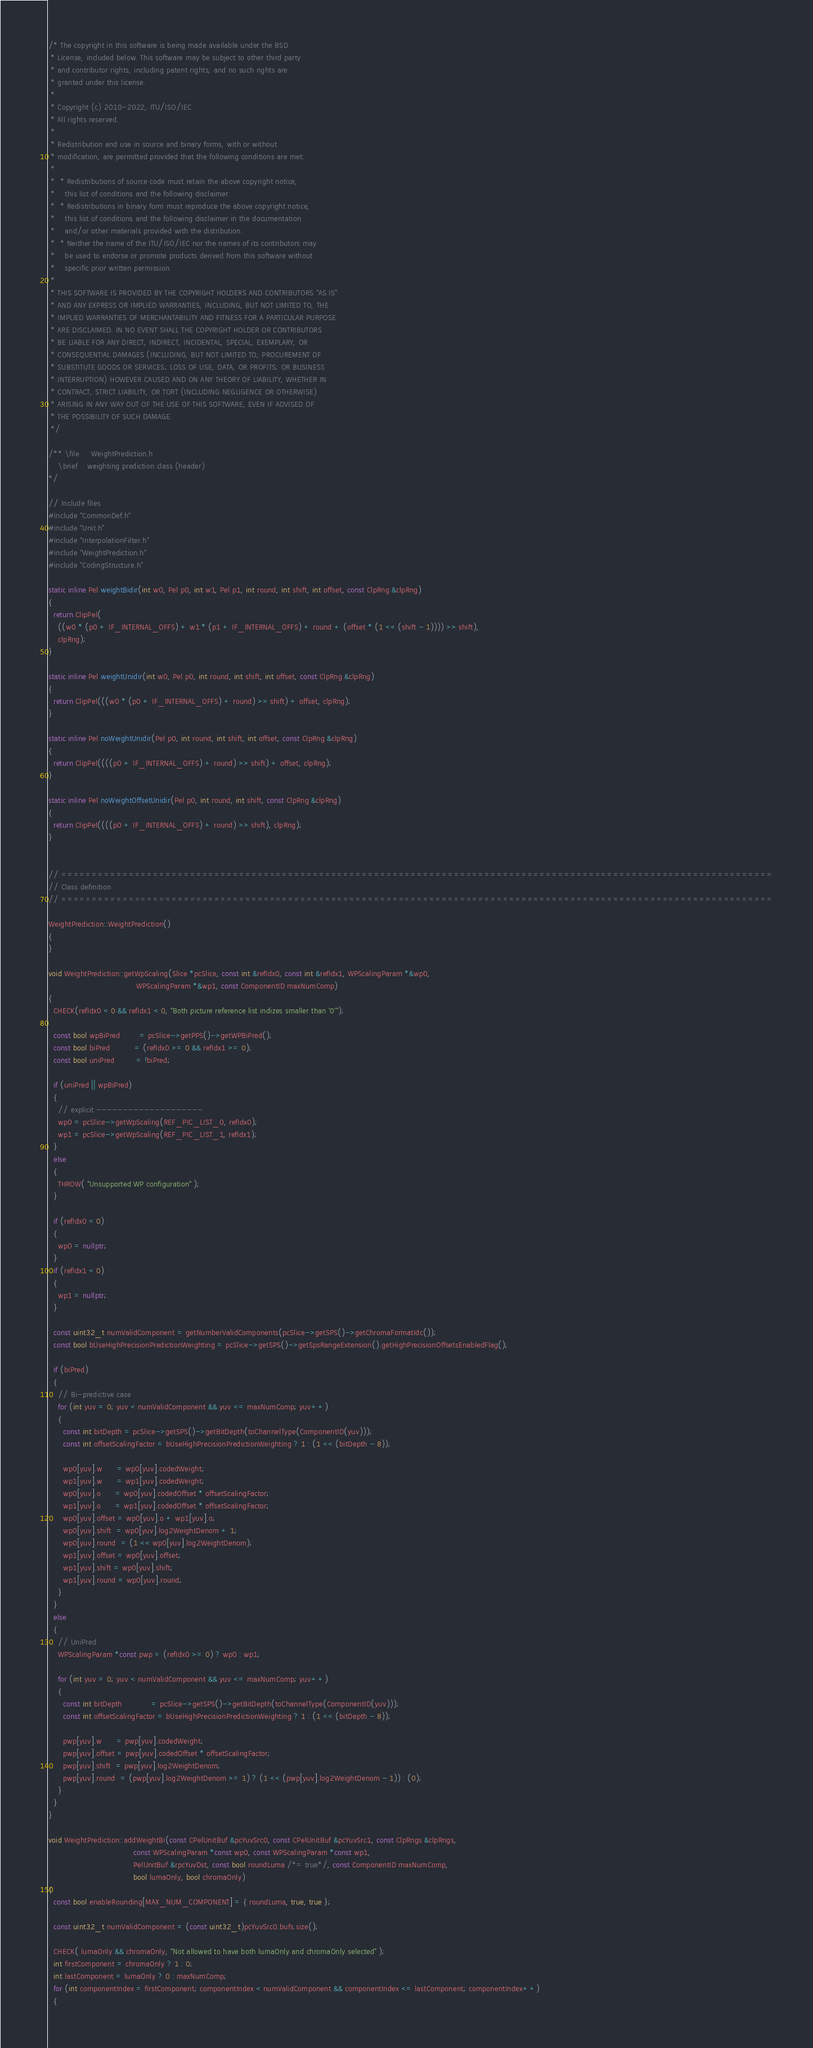Convert code to text. <code><loc_0><loc_0><loc_500><loc_500><_C++_>/* The copyright in this software is being made available under the BSD
 * License, included below. This software may be subject to other third party
 * and contributor rights, including patent rights, and no such rights are
 * granted under this license.
 *
 * Copyright (c) 2010-2022, ITU/ISO/IEC
 * All rights reserved.
 *
 * Redistribution and use in source and binary forms, with or without
 * modification, are permitted provided that the following conditions are met:
 *
 *  * Redistributions of source code must retain the above copyright notice,
 *    this list of conditions and the following disclaimer.
 *  * Redistributions in binary form must reproduce the above copyright notice,
 *    this list of conditions and the following disclaimer in the documentation
 *    and/or other materials provided with the distribution.
 *  * Neither the name of the ITU/ISO/IEC nor the names of its contributors may
 *    be used to endorse or promote products derived from this software without
 *    specific prior written permission.
 *
 * THIS SOFTWARE IS PROVIDED BY THE COPYRIGHT HOLDERS AND CONTRIBUTORS "AS IS"
 * AND ANY EXPRESS OR IMPLIED WARRANTIES, INCLUDING, BUT NOT LIMITED TO, THE
 * IMPLIED WARRANTIES OF MERCHANTABILITY AND FITNESS FOR A PARTICULAR PURPOSE
 * ARE DISCLAIMED. IN NO EVENT SHALL THE COPYRIGHT HOLDER OR CONTRIBUTORS
 * BE LIABLE FOR ANY DIRECT, INDIRECT, INCIDENTAL, SPECIAL, EXEMPLARY, OR
 * CONSEQUENTIAL DAMAGES (INCLUDING, BUT NOT LIMITED TO, PROCUREMENT OF
 * SUBSTITUTE GOODS OR SERVICES; LOSS OF USE, DATA, OR PROFITS; OR BUSINESS
 * INTERRUPTION) HOWEVER CAUSED AND ON ANY THEORY OF LIABILITY, WHETHER IN
 * CONTRACT, STRICT LIABILITY, OR TORT (INCLUDING NEGLIGENCE OR OTHERWISE)
 * ARISING IN ANY WAY OUT OF THE USE OF THIS SOFTWARE, EVEN IF ADVISED OF
 * THE POSSIBILITY OF SUCH DAMAGE.
 */

/** \file     WeightPrediction.h
    \brief    weighting prediction class (header)
*/

// Include files
#include "CommonDef.h"
#include "Unit.h"
#include "InterpolationFilter.h"
#include "WeightPrediction.h"
#include "CodingStructure.h"

static inline Pel weightBidir(int w0, Pel p0, int w1, Pel p1, int round, int shift, int offset, const ClpRng &clpRng)
{
  return ClipPel(
    ((w0 * (p0 + IF_INTERNAL_OFFS) + w1 * (p1 + IF_INTERNAL_OFFS) + round + (offset * (1 << (shift - 1)))) >> shift),
    clpRng);
}

static inline Pel weightUnidir(int w0, Pel p0, int round, int shift, int offset, const ClpRng &clpRng)
{
  return ClipPel(((w0 * (p0 + IF_INTERNAL_OFFS) + round) >> shift) + offset, clpRng);
}

static inline Pel noWeightUnidir(Pel p0, int round, int shift, int offset, const ClpRng &clpRng)
{
  return ClipPel((((p0 + IF_INTERNAL_OFFS) + round) >> shift) + offset, clpRng);
}

static inline Pel noWeightOffsetUnidir(Pel p0, int round, int shift, const ClpRng &clpRng)
{
  return ClipPel((((p0 + IF_INTERNAL_OFFS) + round) >> shift), clpRng);
}


// ====================================================================================================================
// Class definition
// ====================================================================================================================

WeightPrediction::WeightPrediction()
{
}

void WeightPrediction::getWpScaling(Slice *pcSlice, const int &refIdx0, const int &refIdx1, WPScalingParam *&wp0,
                                    WPScalingParam *&wp1, const ComponentID maxNumComp)
{
  CHECK(refIdx0 < 0 && refIdx1 < 0, "Both picture reference list indizes smaller than '0'");

  const bool wpBiPred        = pcSlice->getPPS()->getWPBiPred();
  const bool biPred          = (refIdx0 >= 0 && refIdx1 >= 0);
  const bool uniPred         = !biPred;

  if (uniPred || wpBiPred)
  {
    // explicit --------------------
    wp0 = pcSlice->getWpScaling(REF_PIC_LIST_0, refIdx0);
    wp1 = pcSlice->getWpScaling(REF_PIC_LIST_1, refIdx1);
  }
  else
  {
    THROW( "Unsupported WP configuration" );
  }

  if (refIdx0 < 0)
  {
    wp0 = nullptr;
  }
  if (refIdx1 < 0)
  {
    wp1 = nullptr;
  }

  const uint32_t numValidComponent = getNumberValidComponents(pcSlice->getSPS()->getChromaFormatIdc());
  const bool bUseHighPrecisionPredictionWeighting = pcSlice->getSPS()->getSpsRangeExtension().getHighPrecisionOffsetsEnabledFlag();

  if (biPred)
  {
    // Bi-predictive case
    for (int yuv = 0; yuv < numValidComponent && yuv <= maxNumComp; yuv++)
    {
      const int bitDepth = pcSlice->getSPS()->getBitDepth(toChannelType(ComponentID(yuv)));
      const int offsetScalingFactor = bUseHighPrecisionPredictionWeighting ? 1 : (1 << (bitDepth - 8));

      wp0[yuv].w      = wp0[yuv].codedWeight;
      wp1[yuv].w      = wp1[yuv].codedWeight;
      wp0[yuv].o      = wp0[yuv].codedOffset * offsetScalingFactor;
      wp1[yuv].o      = wp1[yuv].codedOffset * offsetScalingFactor;
      wp0[yuv].offset = wp0[yuv].o + wp1[yuv].o;
      wp0[yuv].shift  = wp0[yuv].log2WeightDenom + 1;
      wp0[yuv].round  = (1 << wp0[yuv].log2WeightDenom);
      wp1[yuv].offset = wp0[yuv].offset;
      wp1[yuv].shift = wp0[yuv].shift;
      wp1[yuv].round = wp0[yuv].round;
    }
  }
  else
  {
    // UniPred
    WPScalingParam *const pwp = (refIdx0 >= 0) ? wp0 : wp1;

    for (int yuv = 0; yuv < numValidComponent && yuv <= maxNumComp; yuv++)
    {
      const int bitDepth            = pcSlice->getSPS()->getBitDepth(toChannelType(ComponentID(yuv)));
      const int offsetScalingFactor = bUseHighPrecisionPredictionWeighting ? 1 : (1 << (bitDepth - 8));

      pwp[yuv].w      = pwp[yuv].codedWeight;
      pwp[yuv].offset = pwp[yuv].codedOffset * offsetScalingFactor;
      pwp[yuv].shift  = pwp[yuv].log2WeightDenom;
      pwp[yuv].round  = (pwp[yuv].log2WeightDenom >= 1) ? (1 << (pwp[yuv].log2WeightDenom - 1)) : (0);
    }
  }
}

void WeightPrediction::addWeightBi(const CPelUnitBuf &pcYuvSrc0, const CPelUnitBuf &pcYuvSrc1, const ClpRngs &clpRngs,
                                   const WPScalingParam *const wp0, const WPScalingParam *const wp1,
                                   PelUnitBuf &rpcYuvDst, const bool roundLuma /*= true*/, const ComponentID maxNumComp,
                                   bool lumaOnly, bool chromaOnly)
{
  const bool enableRounding[MAX_NUM_COMPONENT] = { roundLuma, true, true };

  const uint32_t numValidComponent = (const uint32_t)pcYuvSrc0.bufs.size();

  CHECK( lumaOnly && chromaOnly, "Not allowed to have both lumaOnly and chromaOnly selected" );
  int firstComponent = chromaOnly ? 1 : 0;
  int lastComponent = lumaOnly ? 0 : maxNumComp;
  for (int componentIndex = firstComponent; componentIndex < numValidComponent && componentIndex <= lastComponent; componentIndex++)
  {</code> 